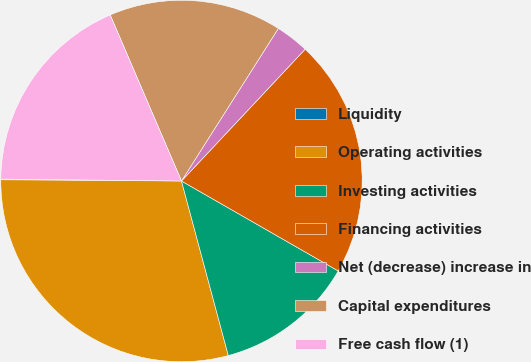<chart> <loc_0><loc_0><loc_500><loc_500><pie_chart><fcel>Liquidity<fcel>Operating activities<fcel>Investing activities<fcel>Financing activities<fcel>Net (decrease) increase in<fcel>Capital expenditures<fcel>Free cash flow (1)<nl><fcel>0.06%<fcel>29.28%<fcel>12.54%<fcel>21.3%<fcel>2.99%<fcel>15.46%<fcel>18.38%<nl></chart> 